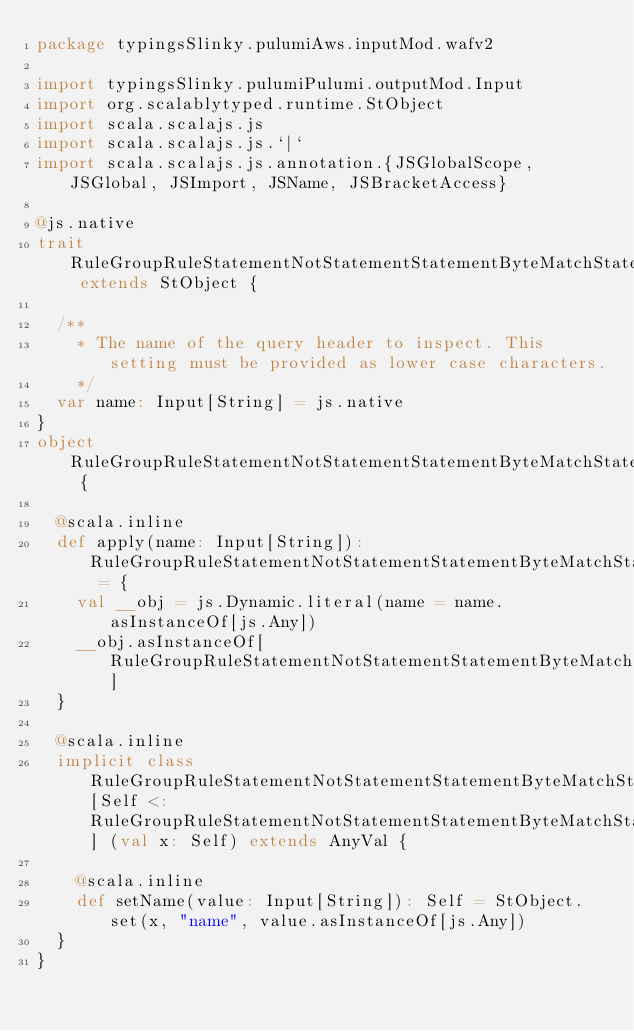Convert code to text. <code><loc_0><loc_0><loc_500><loc_500><_Scala_>package typingsSlinky.pulumiAws.inputMod.wafv2

import typingsSlinky.pulumiPulumi.outputMod.Input
import org.scalablytyped.runtime.StObject
import scala.scalajs.js
import scala.scalajs.js.`|`
import scala.scalajs.js.annotation.{JSGlobalScope, JSGlobal, JSImport, JSName, JSBracketAccess}

@js.native
trait RuleGroupRuleStatementNotStatementStatementByteMatchStatementFieldToMatchSingleHeader extends StObject {
  
  /**
    * The name of the query header to inspect. This setting must be provided as lower case characters.
    */
  var name: Input[String] = js.native
}
object RuleGroupRuleStatementNotStatementStatementByteMatchStatementFieldToMatchSingleHeader {
  
  @scala.inline
  def apply(name: Input[String]): RuleGroupRuleStatementNotStatementStatementByteMatchStatementFieldToMatchSingleHeader = {
    val __obj = js.Dynamic.literal(name = name.asInstanceOf[js.Any])
    __obj.asInstanceOf[RuleGroupRuleStatementNotStatementStatementByteMatchStatementFieldToMatchSingleHeader]
  }
  
  @scala.inline
  implicit class RuleGroupRuleStatementNotStatementStatementByteMatchStatementFieldToMatchSingleHeaderMutableBuilder[Self <: RuleGroupRuleStatementNotStatementStatementByteMatchStatementFieldToMatchSingleHeader] (val x: Self) extends AnyVal {
    
    @scala.inline
    def setName(value: Input[String]): Self = StObject.set(x, "name", value.asInstanceOf[js.Any])
  }
}
</code> 